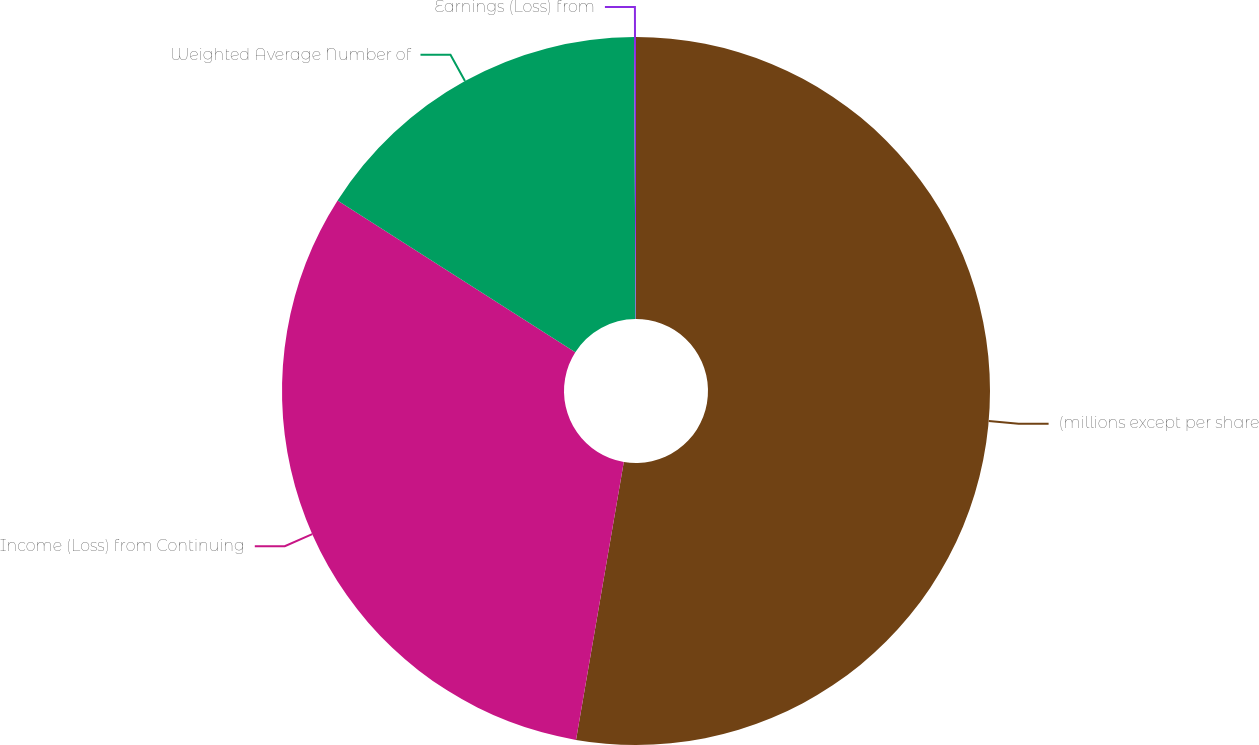<chart> <loc_0><loc_0><loc_500><loc_500><pie_chart><fcel>(millions except per share<fcel>Income (Loss) from Continuing<fcel>Weighted Average Number of<fcel>Earnings (Loss) from<nl><fcel>52.71%<fcel>31.33%<fcel>15.87%<fcel>0.09%<nl></chart> 